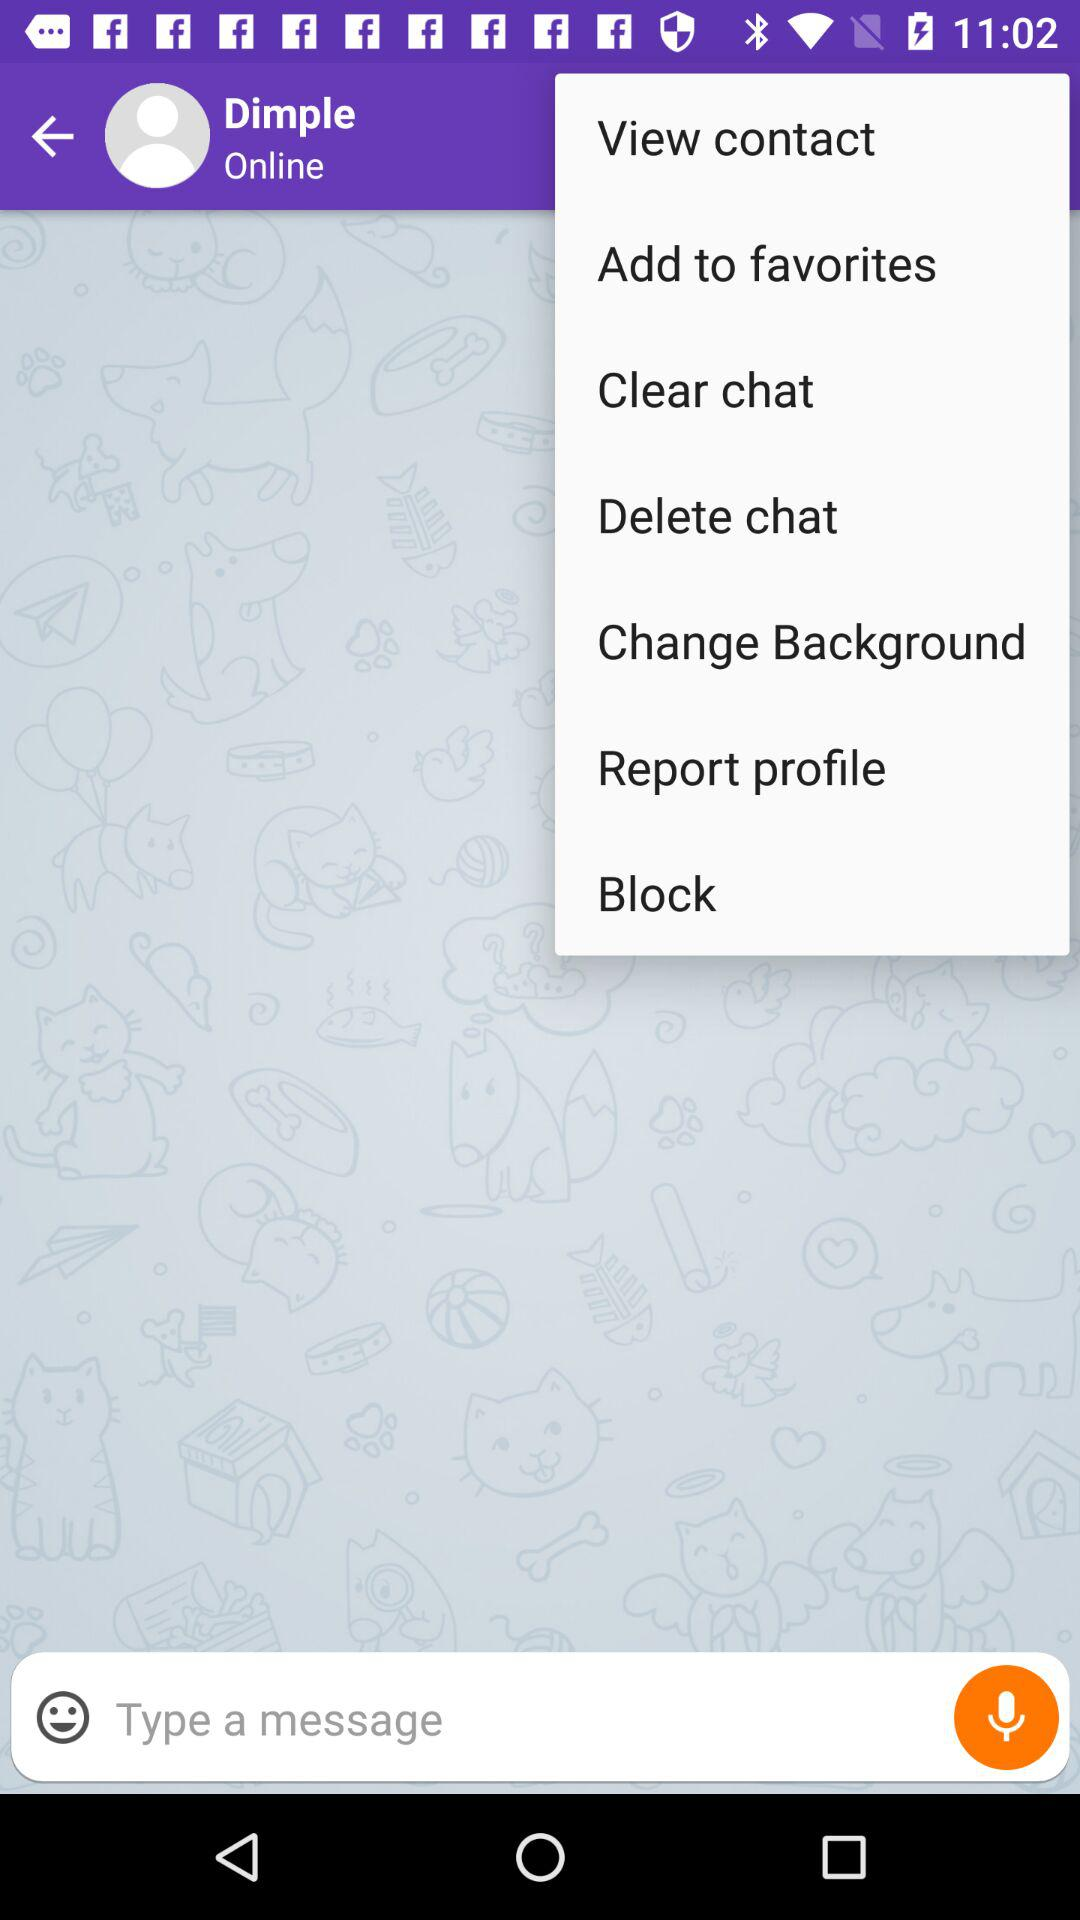What is the status of the user? The user is online. 